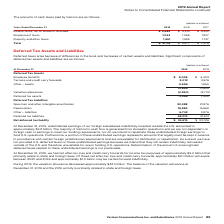Looking at Verizon Communications's financial data, please calculate: What was the change in the employee benefit from 2018 to 2019? Based on the calculation: 5,048 - 5,403, the result is -355 (in millions). This is based on the information: "Employee benefits $ 5,048 $ 5,403 Employee benefits $ 5,048 $ 5,403..." The key data points involved are: 5,048, 5,403. Also, can you calculate: What was the average tax loss and credit carry forward for 2018 and 2019? To answer this question, I need to perform calculations using the financial data. The calculation is: (3,012 + 3,576) / 2, which equals 3294 (in millions). This is based on the information: "Tax loss and credit carry forwards 3,012 3,576 Tax loss and credit carry forwards 3,012 3,576..." The key data points involved are: 3,012, 3,576. Also, can you calculate: What was the average other assets for 2018 and 2019? To answer this question, I need to perform calculations using the financial data. The calculation is: (5,595 + 1,650) / 2, which equals 3622.5 (in millions). This is based on the information: "Other – assets 5,595 1,650 Other – assets 5,595 1,650..." The key data points involved are: 1,650, 5,595. Also, What was the undistributed earnings of foreign subsidiary invested outside the US amounted to in 2019? According to the financial document, $3.8 billion. The relevant text states: "nvested outside the U.S. amounted to approximately $3.8 billion. The majority of Verizon’s cash flow is generated from domestic operations and we are not dependent..." Also, What was the net after tax loss and credit carry forward for income tax in 2019? According to the financial document, $3.0 billion. The relevant text states: "forwards for income tax purposes of approximately $3.0 billion that primarily relate to state and foreign taxes. Of these net after-tax loss and credit carry forwa..." Also, What was the valuation allowance decrease in 2019? According to the financial document, $481 million. The relevant text states: "9, the valuation allowance decreased approximately $481 million. The balance of the valuation allowance at December 31, 2019 and the 2019 activity is primarily rel..." 